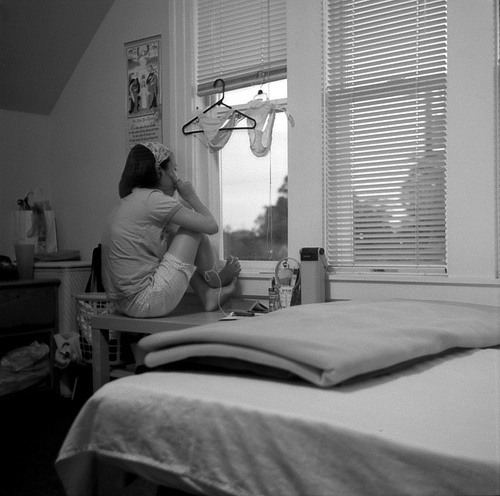Describe the objects in this image and their specific colors. I can see bed in black, darkgray, gray, and silver tones, people in gray and black tones, and cell phone in black, gray, and darkgray tones in this image. 